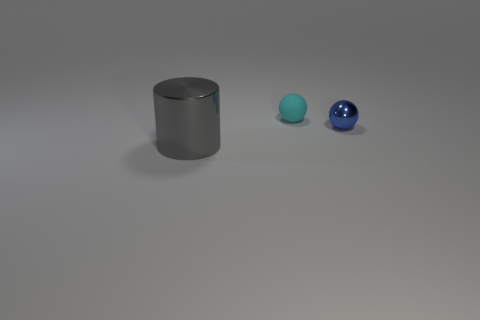Is there any other thing that is the same material as the cyan object?
Keep it short and to the point. No. There is a metal thing that is behind the large thing; is it the same color as the rubber thing?
Your answer should be compact. No. Is there any other thing that is the same color as the tiny rubber ball?
Your answer should be compact. No. What is the color of the metallic thing that is right of the tiny sphere left of the tiny ball that is to the right of the cyan sphere?
Offer a terse response. Blue. Is the metallic cylinder the same size as the blue sphere?
Offer a terse response. No. How many cylinders are the same size as the cyan rubber thing?
Provide a short and direct response. 0. Is the tiny object that is left of the blue ball made of the same material as the large cylinder that is left of the blue metal ball?
Ensure brevity in your answer.  No. Is there anything else that is the same shape as the gray metallic object?
Give a very brief answer. No. The large metallic cylinder is what color?
Make the answer very short. Gray. How many tiny cyan matte objects are the same shape as the tiny blue object?
Your answer should be very brief. 1. 